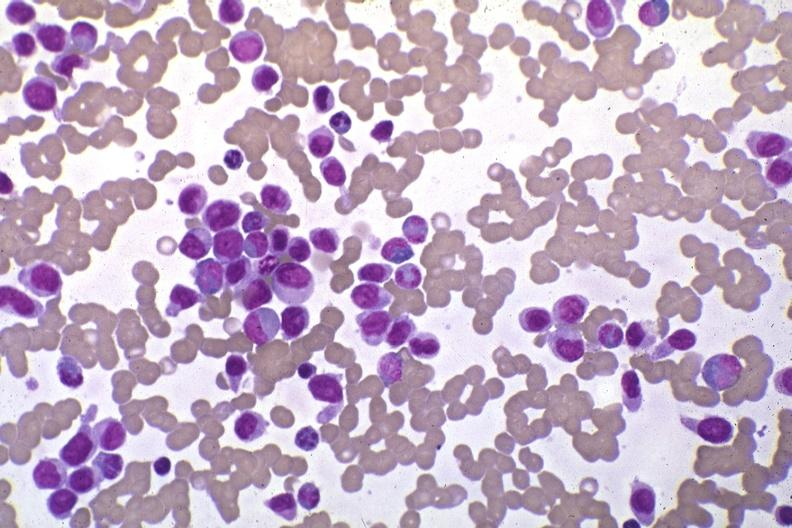s blood present?
Answer the question using a single word or phrase. Yes 